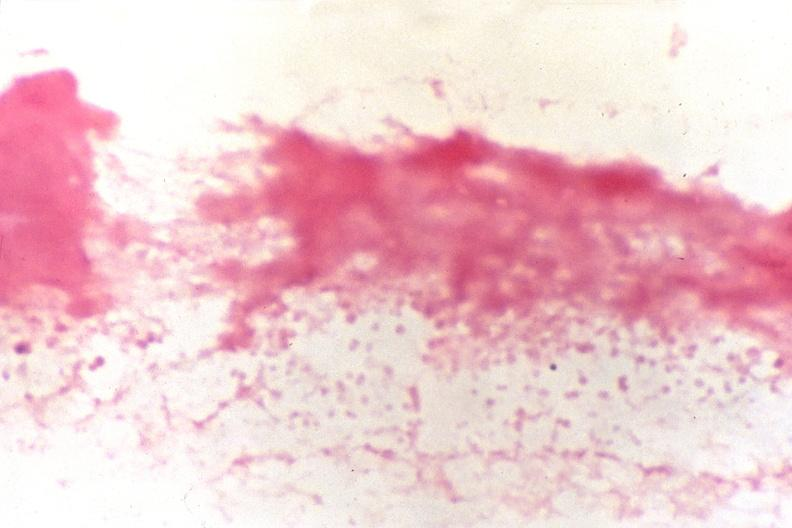what is present?
Answer the question using a single word or phrase. Cerebrospinal fluid 